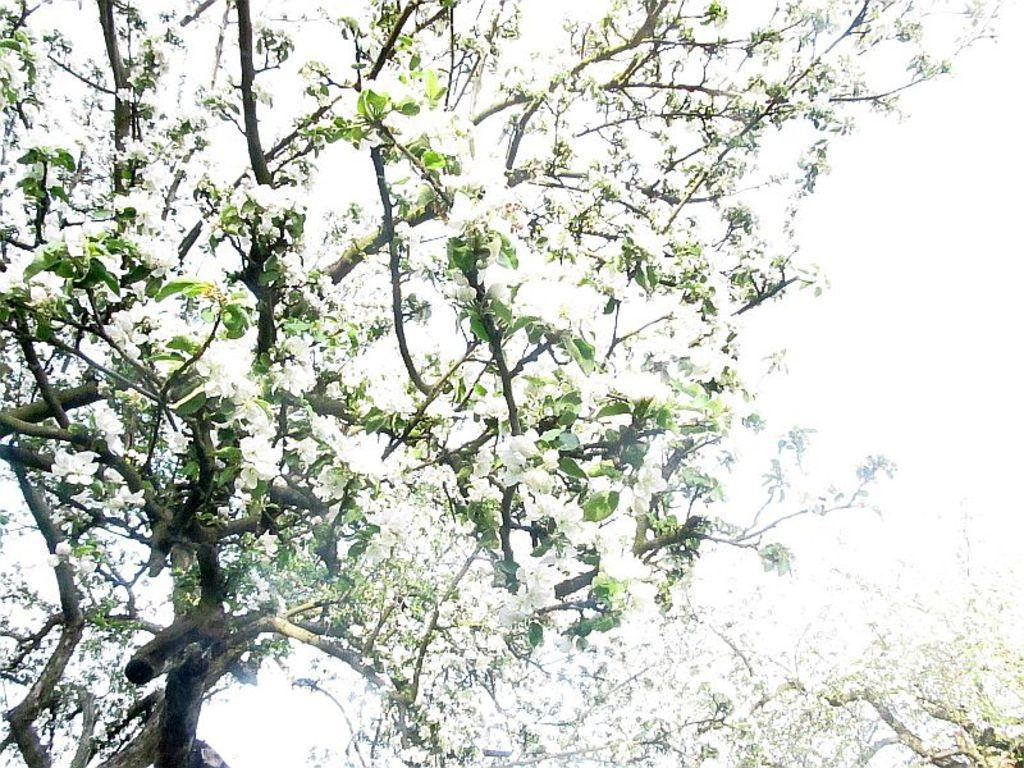What is located in the center of the image? There are trees in the center of the image. What can be observed on the trees in the image? The trees have blossoms. What is visible in the background of the image? The sky is visible in the background of the image. How many planes can be seen flying over the trees in the image? There are no planes visible in the image; it only features trees with blossoms and a visible sky in the background. What type of wave can be seen crashing onto the shore in the image? There is no wave or shore present in the image; it only features trees with blossoms and a visible sky in the background. 